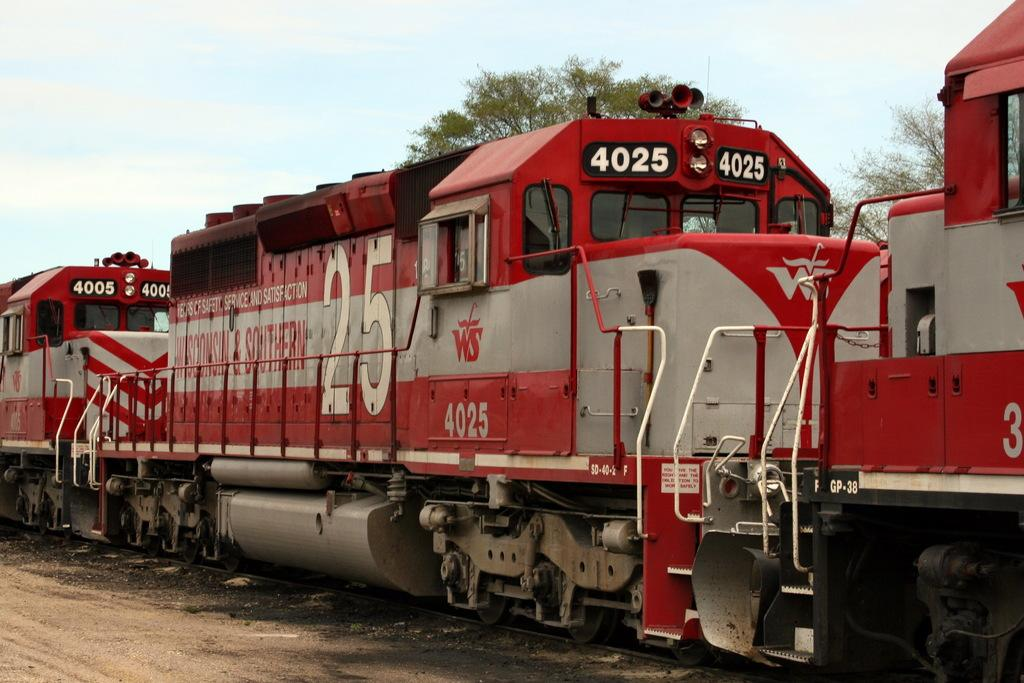What is the main subject in the foreground of the image? There is a train in the foreground of the image. What is the train's position in relation to the track? The train is on a track. What can be seen in the background of the image? There are trees and the sky visible in the background of the image. What is the condition of the sky in the image? The sky has clouds in it. How many pencils are being used by the partner in the image? There is no partner present in the image, and therefore no pencils are being used. 